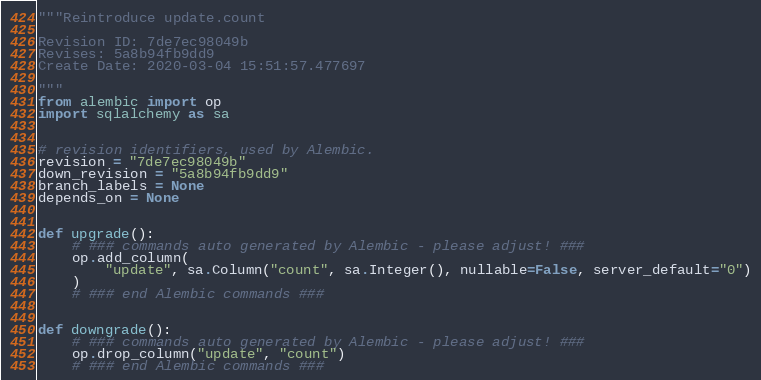Convert code to text. <code><loc_0><loc_0><loc_500><loc_500><_Python_>"""Reintroduce update.count

Revision ID: 7de7ec98049b
Revises: 5a8b94fb9dd9
Create Date: 2020-03-04 15:51:57.477697

"""
from alembic import op
import sqlalchemy as sa


# revision identifiers, used by Alembic.
revision = "7de7ec98049b"
down_revision = "5a8b94fb9dd9"
branch_labels = None
depends_on = None


def upgrade():
    # ### commands auto generated by Alembic - please adjust! ###
    op.add_column(
        "update", sa.Column("count", sa.Integer(), nullable=False, server_default="0")
    )
    # ### end Alembic commands ###


def downgrade():
    # ### commands auto generated by Alembic - please adjust! ###
    op.drop_column("update", "count")
    # ### end Alembic commands ###
</code> 